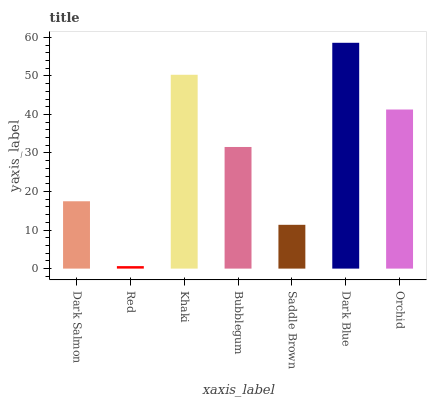Is Red the minimum?
Answer yes or no. Yes. Is Dark Blue the maximum?
Answer yes or no. Yes. Is Khaki the minimum?
Answer yes or no. No. Is Khaki the maximum?
Answer yes or no. No. Is Khaki greater than Red?
Answer yes or no. Yes. Is Red less than Khaki?
Answer yes or no. Yes. Is Red greater than Khaki?
Answer yes or no. No. Is Khaki less than Red?
Answer yes or no. No. Is Bubblegum the high median?
Answer yes or no. Yes. Is Bubblegum the low median?
Answer yes or no. Yes. Is Red the high median?
Answer yes or no. No. Is Saddle Brown the low median?
Answer yes or no. No. 